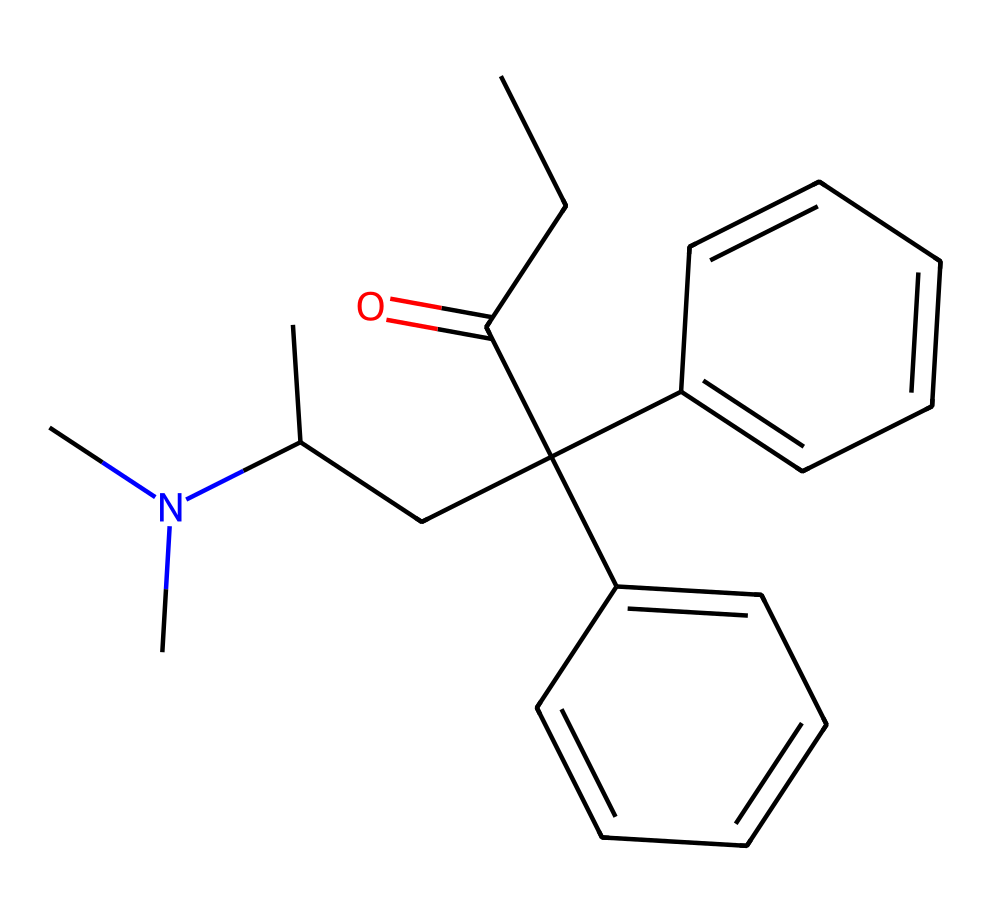how many nitrogen atoms are present in this chemical structure? The SMILES representation indicates the presence of a nitrogen atom denoted by 'N'. By examining the structure, you can see that there are 2 nitrogen atoms, one within the side chain and one in the tertiary amine grouping and thus, the count is 2.
Answer: 2 what is the functional group associated with methadone in this structure? The part of the chemical structure that indicates a functional group can be observed through the presence of the amine (N) and the ketone (C=O). The ketone appears with the carbonyl group attached to the carbon chain. Therefore, methadone contains a ketone functional group.
Answer: ketone how many benzene rings are included in the structure? Upon examining the SMILES, the term 'c' indicates aromatic carbon atoms. The structure contains two distinct sets of aromatic rings, confirming that there are 2 benzene rings.
Answer: 2 is this chemical polar or nonpolar? To determine polarity, one must consider the presence of functional groups and asymmetry in the structure. Given that methadone contains polar functional groups (e.g., amine) in a relatively complex carbon framework, it would indicate polarity. Therefore, the overall character is polar.
Answer: polar what type of chemical is methadone classified as? Methadone, based on its structure featuring carbon, hydrogen, and nitrogen, belongs to the class of compounds known as opiates. This classification is consistent with its use in medical treatment.
Answer: opiate what type of bonding is primarily found in this chemical structure? The structure features primarily covalent bonds due to the sharing of electrons among the carbon, hydrogen, and nitrogen atoms. The presence of aromatic systems (benzene rings) further illustrates the dominance of covalent bonding in this compound.
Answer: covalent 